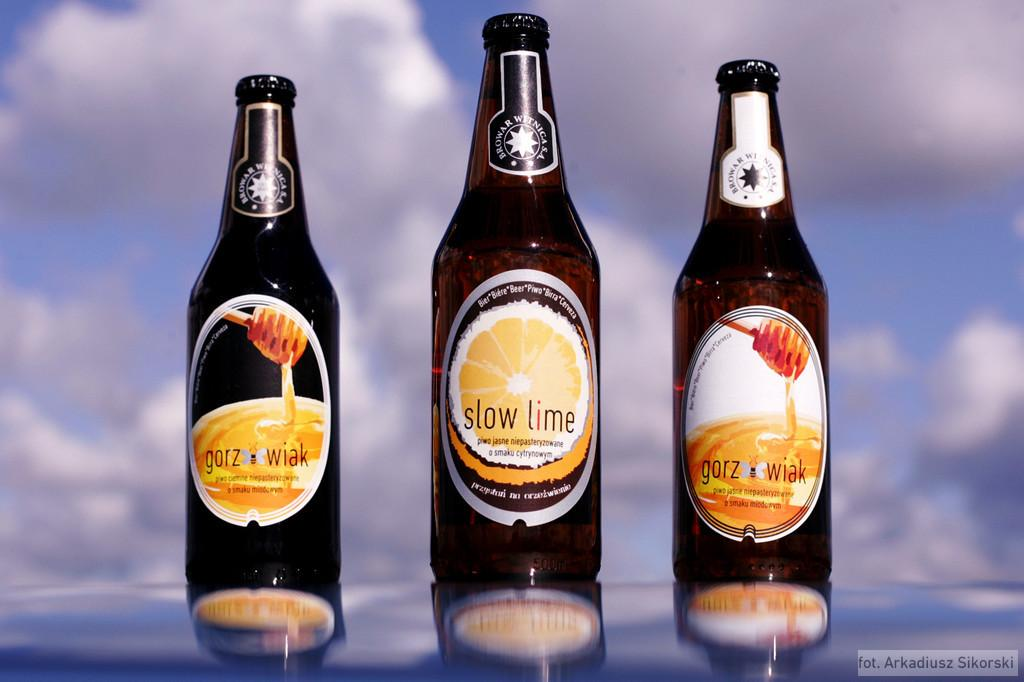<image>
Give a short and clear explanation of the subsequent image. Three bottles of beer by Browar Witniga stand in a row 